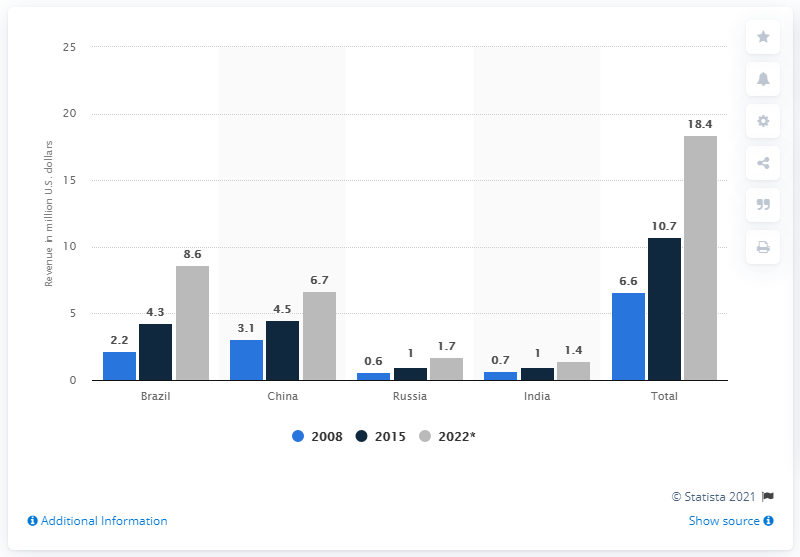Outline some significant characteristics in this image. The value of the remote patient monitoring market in BRIC countries in 2015 was estimated to be 10.7 billion dollars. 